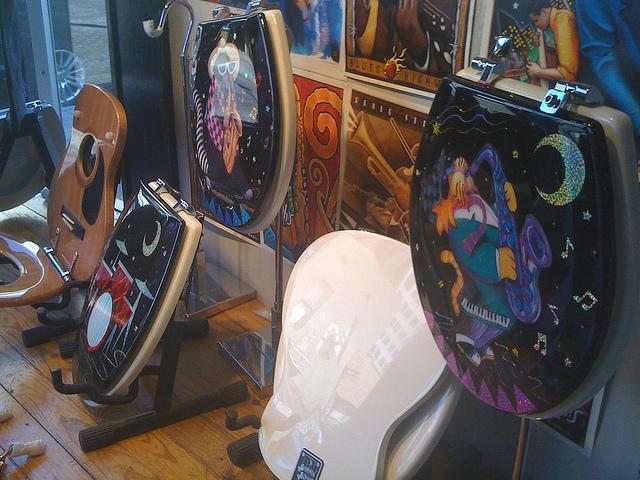How many of the lids are shaped like guitars?
Give a very brief answer. 2. How many toilets are visible?
Give a very brief answer. 5. How many chairs are in the picture?
Give a very brief answer. 0. 